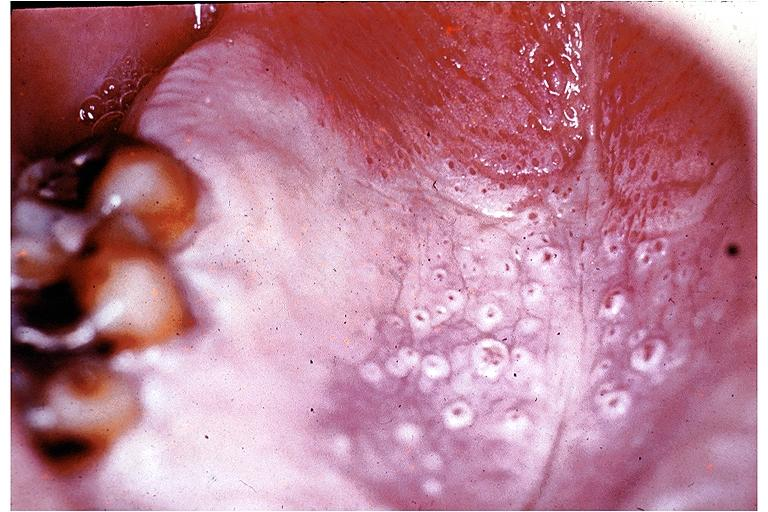where is this?
Answer the question using a single word or phrase. Oral 